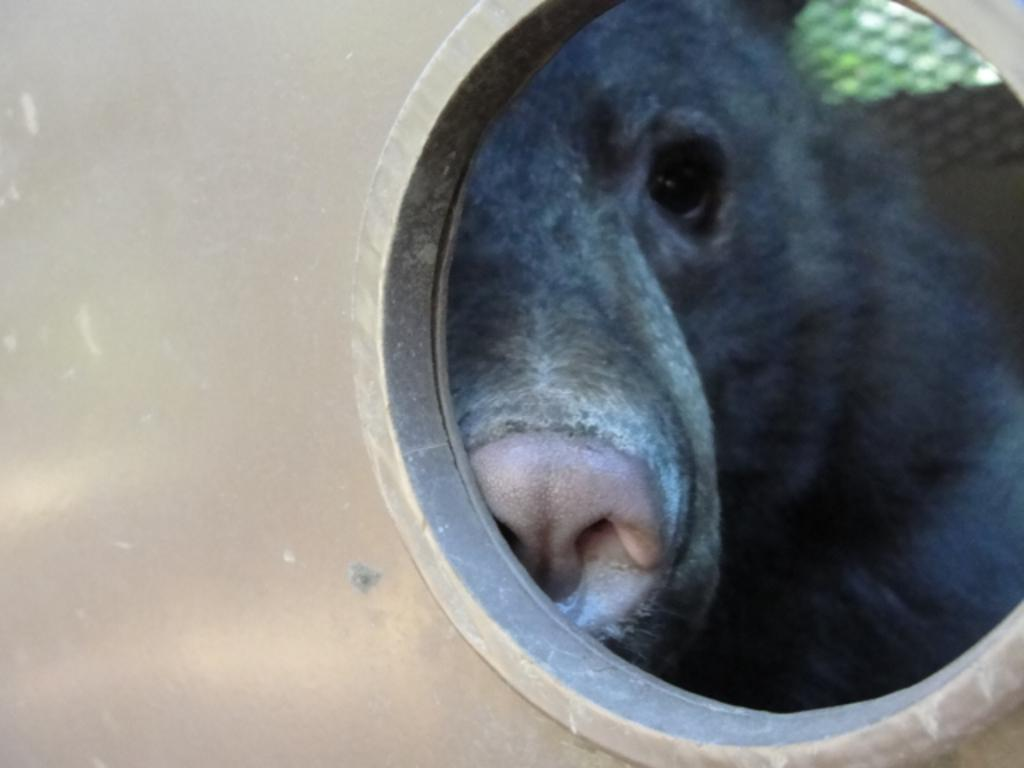What type of structure is present in the image? There is a metal structure in the image. Can you describe any specific features of the metal structure? Yes, there is a hole in the metal structure. What can be seen through the hole in the metal structure? An animal is visible through the hole in the metal structure. How is the glue being used in the image? There is no glue present in the image. What type of trees are visible in the image? There is no mention of trees in the provided facts, so we cannot determine if any trees are visible in the image. 